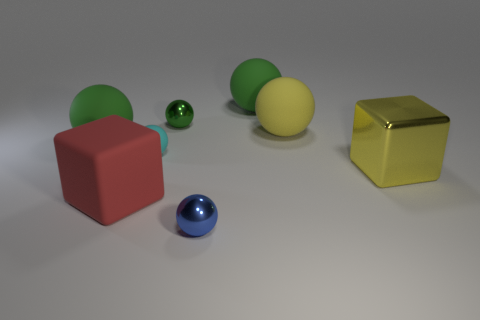What number of objects are either yellow shiny blocks or big yellow things that are behind the yellow shiny thing?
Provide a short and direct response. 2. There is a sphere that is the same color as the large metallic thing; what is its material?
Offer a very short reply. Rubber. Do the cube that is in front of the yellow shiny block and the yellow shiny object have the same size?
Offer a terse response. Yes. There is a big yellow object to the left of the block that is right of the blue sphere; what number of yellow cubes are on the left side of it?
Provide a short and direct response. 0. How many red objects are either small spheres or matte objects?
Offer a terse response. 1. There is a cube that is the same material as the large yellow sphere; what color is it?
Ensure brevity in your answer.  Red. Is there anything else that has the same size as the cyan object?
Keep it short and to the point. Yes. How many tiny objects are purple things or cyan balls?
Your answer should be very brief. 1. Are there fewer large cubes than big brown cubes?
Offer a very short reply. No. The small rubber thing that is the same shape as the tiny blue metallic object is what color?
Keep it short and to the point. Cyan. 